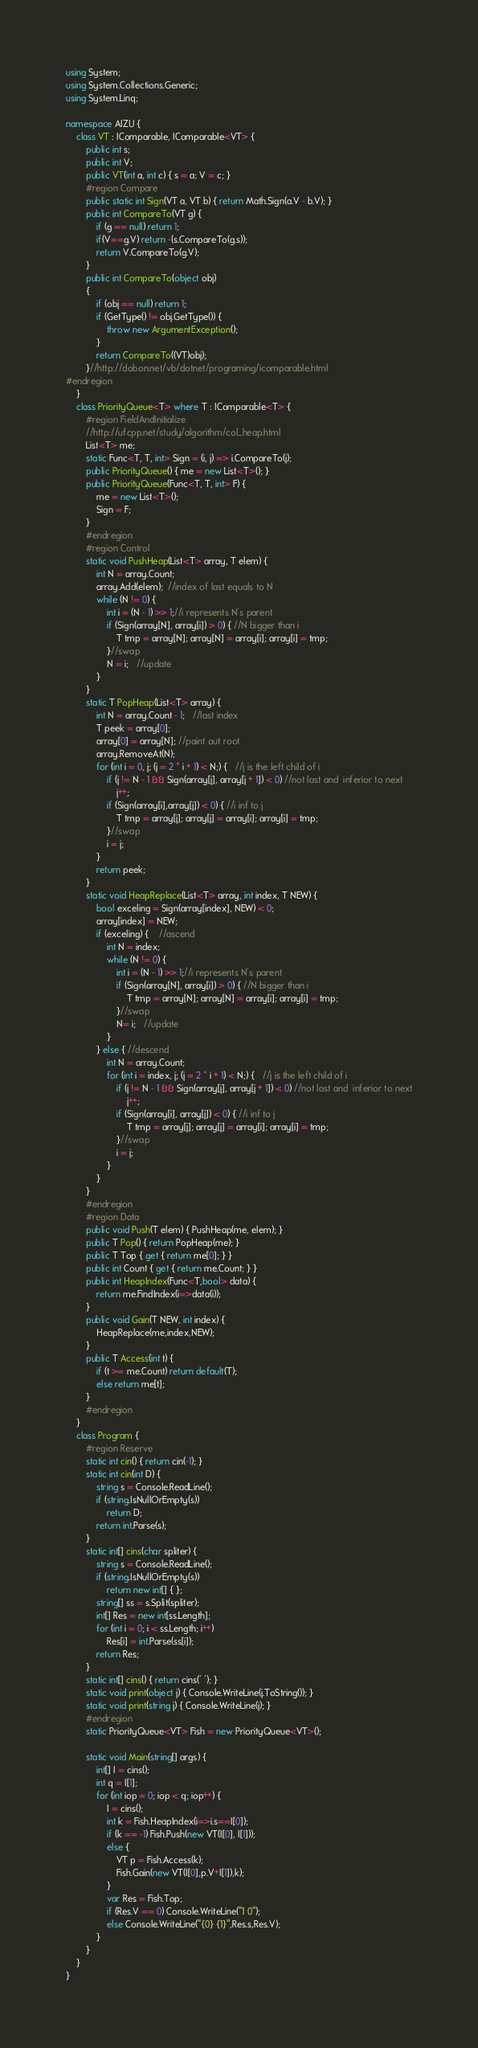<code> <loc_0><loc_0><loc_500><loc_500><_C#_>using System;
using System.Collections.Generic;
using System.Linq;

namespace AIZU {
	class VT : IComparable, IComparable<VT> {
		public int s;
		public int V;
		public VT(int a, int c) { s = a; V = c; }
		#region Compare
		public static int Sign(VT a, VT b) { return Math.Sign(a.V - b.V); }
		public int CompareTo(VT g) {
			if (g == null) return 1;
			if(V==g.V) return -(s.CompareTo(g.s));
			return V.CompareTo(g.V);
		}
		public int CompareTo(object obj)
		{
			if (obj == null) return 1;
			if (GetType() != obj.GetType()) {
				throw new ArgumentException();
			}
			return CompareTo((VT)obj);
		}//http://dobon.net/vb/dotnet/programing/icomparable.html
#endregion
	}
	class PriorityQueue<T> where T : IComparable<T> {
		#region FieldAndInitialize
		//http://ufcpp.net/study/algorithm/col_heap.html
		List<T> me;
		static Func<T, T, int> Sign = (i, j) => i.CompareTo(j);
		public PriorityQueue() { me = new List<T>(); }
		public PriorityQueue(Func<T, T, int> F) {
			me = new List<T>();
			Sign = F;
		}
		#endregion
		#region Control
		static void PushHeap(List<T> array, T elem) {
			int N = array.Count;
			array.Add(elem);  //index of last equals to N
			while (N != 0) {
				int i = (N - 1) >> 1;//i represents N's parent
				if (Sign(array[N], array[i]) > 0) { //N bigger than i
					T tmp = array[N]; array[N] = array[i]; array[i] = tmp;
				}//swap
				N = i;   //update
			}
		}
		static T PopHeap(List<T> array) {
			int N = array.Count - 1;   //last index
			T peek = array[0];
			array[0] = array[N]; //paint out root
			array.RemoveAt(N);
			for (int i = 0, j; (j = 2 * i + 1) < N;) {   //j is the left child of i
				if (j != N - 1 && Sign(array[j], array[j + 1]) < 0) //not last and  inferior to next
					j++;
				if (Sign(array[i],array[j]) < 0) { //i inf to j
					T tmp = array[j]; array[j] = array[i]; array[i] = tmp;
				}//swap
				i = j;
			}
			return peek;
		}
		static void HeapReplace(List<T> array, int index, T NEW) {
			bool exceling = Sign(array[index], NEW) < 0;
			array[index] = NEW;
			if (exceling) {	//ascend
				int N = index;
				while (N != 0) {
					int i = (N - 1) >> 1;//i represents N's parent
					if (Sign(array[N], array[i]) > 0) { //N bigger than i
						T tmp = array[N]; array[N] = array[i]; array[i] = tmp;
					}//swap
					N= i;   //update
				}
			} else { //descend
				int N = array.Count;
				for (int i = index, j; (j = 2 * i + 1) < N;) {   //j is the left child of i
					if (j != N - 1 && Sign(array[j], array[j + 1]) < 0) //not last and  inferior to next
						j++;
					if (Sign(array[i], array[j]) < 0) { //i inf to j
						T tmp = array[j]; array[j] = array[i]; array[i] = tmp;
					}//swap
					i = j;
				}
			}
		}
		#endregion
		#region Data
		public void Push(T elem) { PushHeap(me, elem); }
		public T Pop() { return PopHeap(me); }
		public T Top { get { return me[0]; } }
		public int Count { get { return me.Count; } }
		public int HeapIndex(Func<T,bool> data) {
			return me.FindIndex(i=>data(i));
		}
		public void Gain(T NEW, int index) {
			HeapReplace(me,index,NEW);
		}
		public T Access(int t) {
			if (t >= me.Count) return default(T);
			else return me[t];
		}
		#endregion
	}
	class Program {
		#region Reserve
		static int cin() { return cin(-1); }
		static int cin(int D) {
			string s = Console.ReadLine();
			if (string.IsNullOrEmpty(s))
				return D;
			return int.Parse(s);
		}
		static int[] cins(char spliter) {
			string s = Console.ReadLine();
			if (string.IsNullOrEmpty(s))
				return new int[] { };
			string[] ss = s.Split(spliter);
			int[] Res = new int[ss.Length];
			for (int i = 0; i < ss.Length; i++)
				Res[i] = int.Parse(ss[i]);
			return Res;
		}
		static int[] cins() { return cins(' '); }
		static void print(object j) { Console.WriteLine(j.ToString()); }
		static void print(string j) { Console.WriteLine(j); }
		#endregion
		static PriorityQueue<VT> Fish = new PriorityQueue<VT>();

		static void Main(string[] args) {
			int[] I = cins();
			int q = I[1];
			for (int iop = 0; iop < q; iop++) {
				I = cins();
				int k = Fish.HeapIndex(i=>i.s==I[0]);
				if (k == -1) Fish.Push(new VT(I[0], I[1]));
				else {
					VT p = Fish.Access(k);
					Fish.Gain(new VT(I[0],p.V+I[1]),k);
				}
				var Res = Fish.Top;
				if (Res.V == 0) Console.WriteLine("1 0");
				else Console.WriteLine("{0} {1}",Res.s,Res.V);
			}
		}
	}
}</code> 